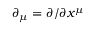<formula> <loc_0><loc_0><loc_500><loc_500>\partial _ { \mu } = \partial / \partial x ^ { \mu }</formula> 